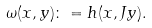Convert formula to latex. <formula><loc_0><loc_0><loc_500><loc_500>\omega ( x , y ) \colon = h ( x , J y ) .</formula> 